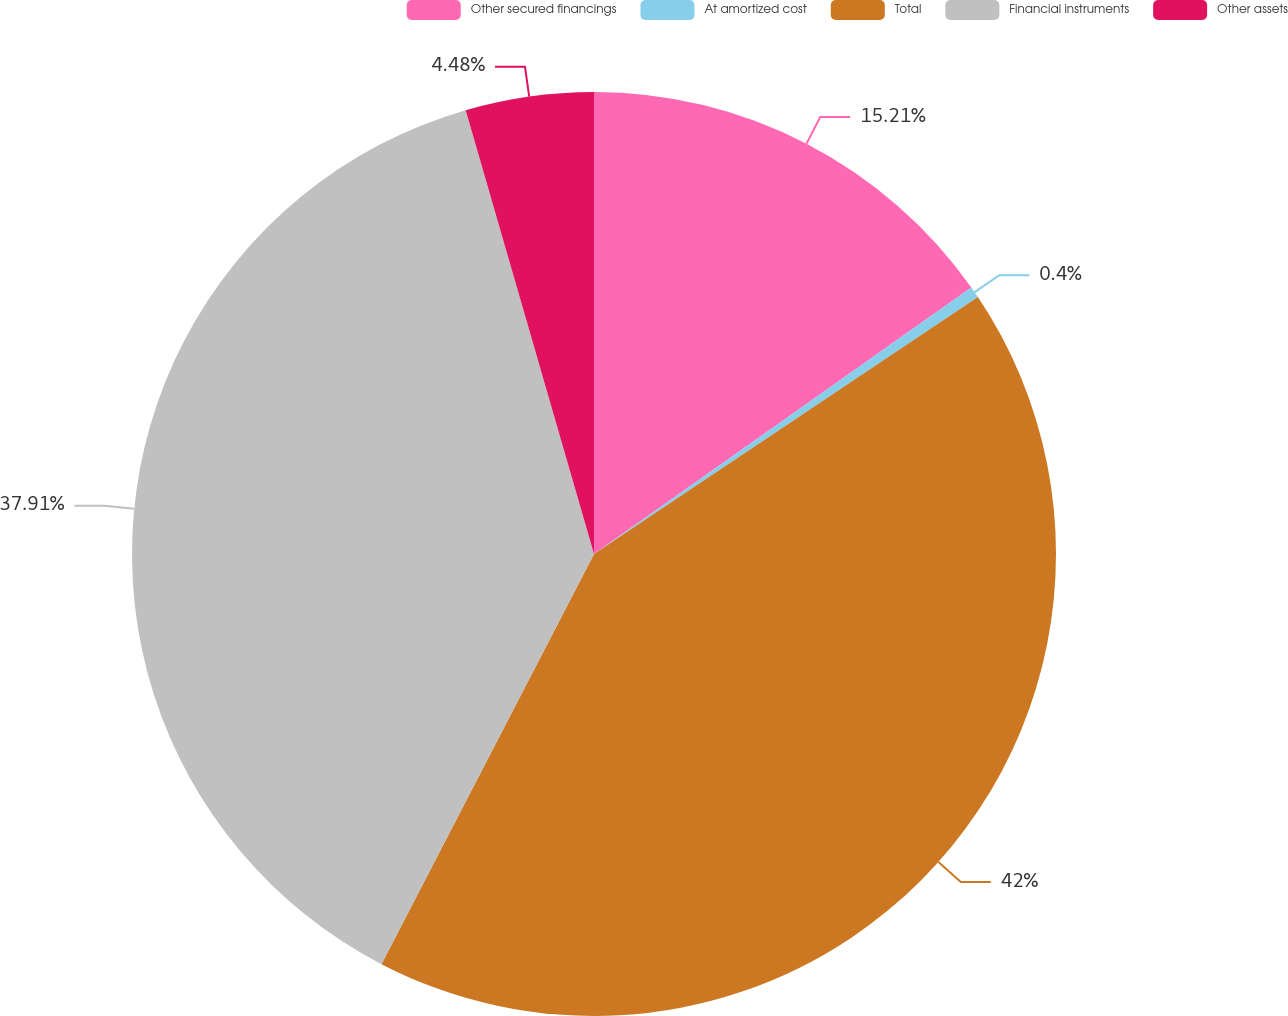Convert chart to OTSL. <chart><loc_0><loc_0><loc_500><loc_500><pie_chart><fcel>Other secured financings<fcel>At amortized cost<fcel>Total<fcel>Financial instruments<fcel>Other assets<nl><fcel>15.21%<fcel>0.4%<fcel>42.0%<fcel>37.91%<fcel>4.48%<nl></chart> 